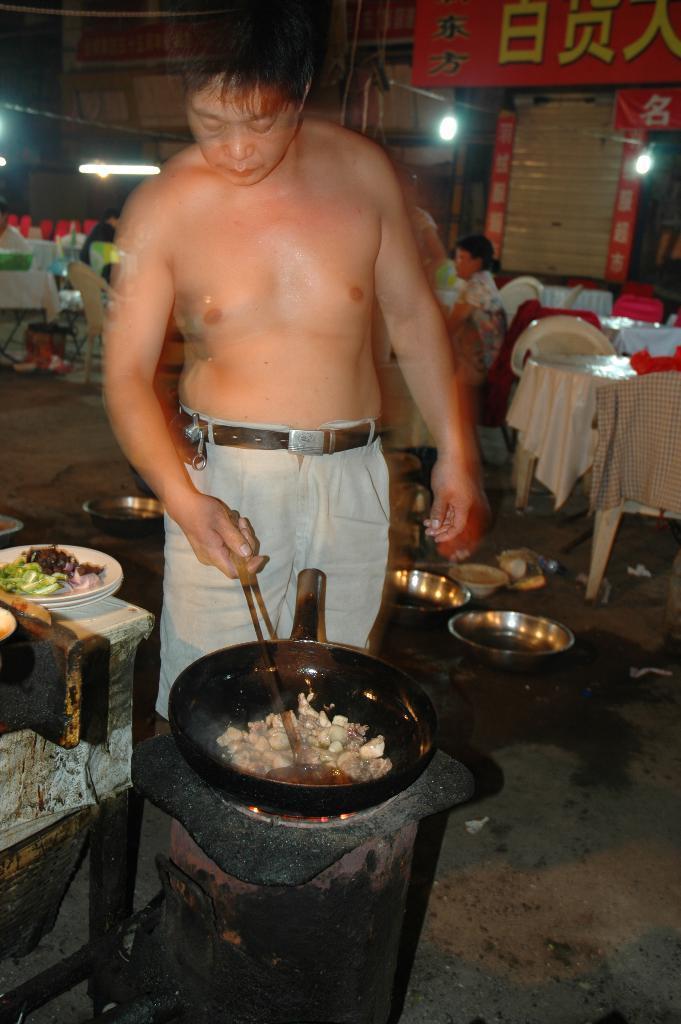How would you summarize this image in a sentence or two? In the image we can see there is a an who is standing and he is cooking a dish in a bowl and beside there is a table on which there are food items and at the back people are sitting on chair. 